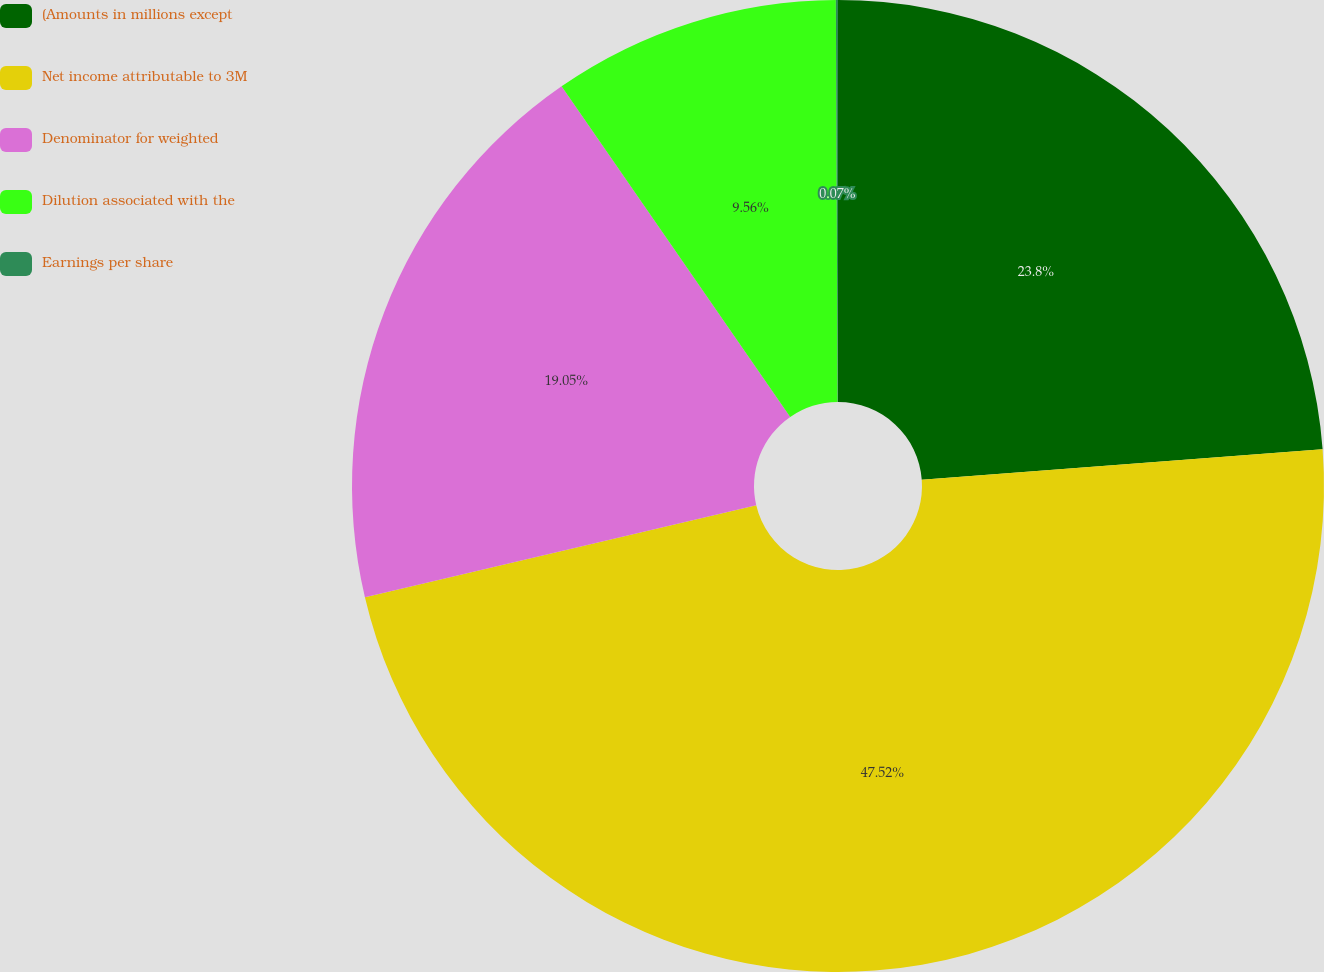Convert chart to OTSL. <chart><loc_0><loc_0><loc_500><loc_500><pie_chart><fcel>(Amounts in millions except<fcel>Net income attributable to 3M<fcel>Denominator for weighted<fcel>Dilution associated with the<fcel>Earnings per share<nl><fcel>23.8%<fcel>47.53%<fcel>19.05%<fcel>9.56%<fcel>0.07%<nl></chart> 